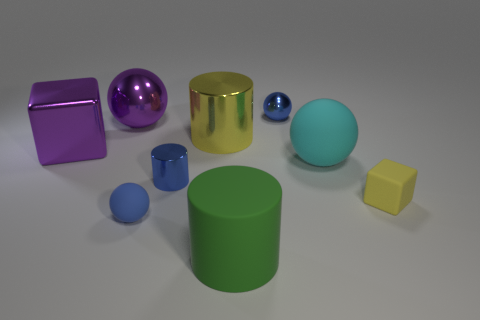What material is the cube left of the tiny shiny object that is in front of the small shiny sphere made of?
Your response must be concise. Metal. Is the number of cyan balls that are to the right of the purple shiny sphere the same as the number of tiny spheres?
Your answer should be very brief. No. Is there anything else that has the same material as the large yellow cylinder?
Give a very brief answer. Yes. Do the tiny sphere behind the big cube and the matte ball on the left side of the cyan rubber object have the same color?
Provide a short and direct response. Yes. How many rubber things are both on the right side of the big cyan matte thing and in front of the tiny matte sphere?
Provide a succinct answer. 0. How many other objects are the same shape as the large green object?
Keep it short and to the point. 2. Are there more small blue cylinders right of the large matte cylinder than small yellow rubber cubes?
Your response must be concise. No. What color is the large cylinder that is in front of the large metal cube?
Offer a terse response. Green. There is a metallic thing that is the same color as the metal block; what size is it?
Provide a succinct answer. Large. What number of metallic objects are small things or blue cubes?
Offer a terse response. 2. 